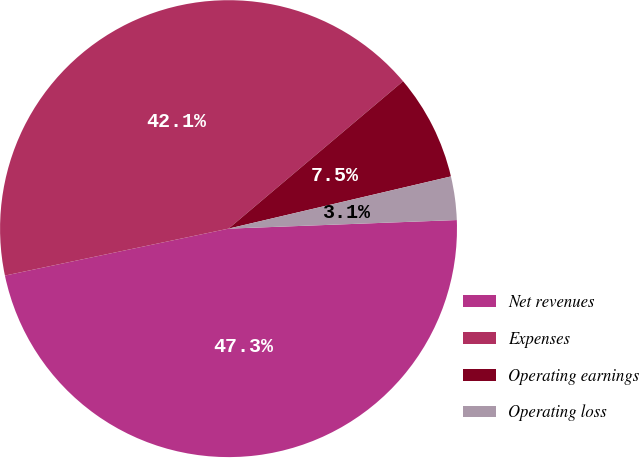Convert chart to OTSL. <chart><loc_0><loc_0><loc_500><loc_500><pie_chart><fcel>Net revenues<fcel>Expenses<fcel>Operating earnings<fcel>Operating loss<nl><fcel>47.3%<fcel>42.13%<fcel>7.49%<fcel>3.07%<nl></chart> 